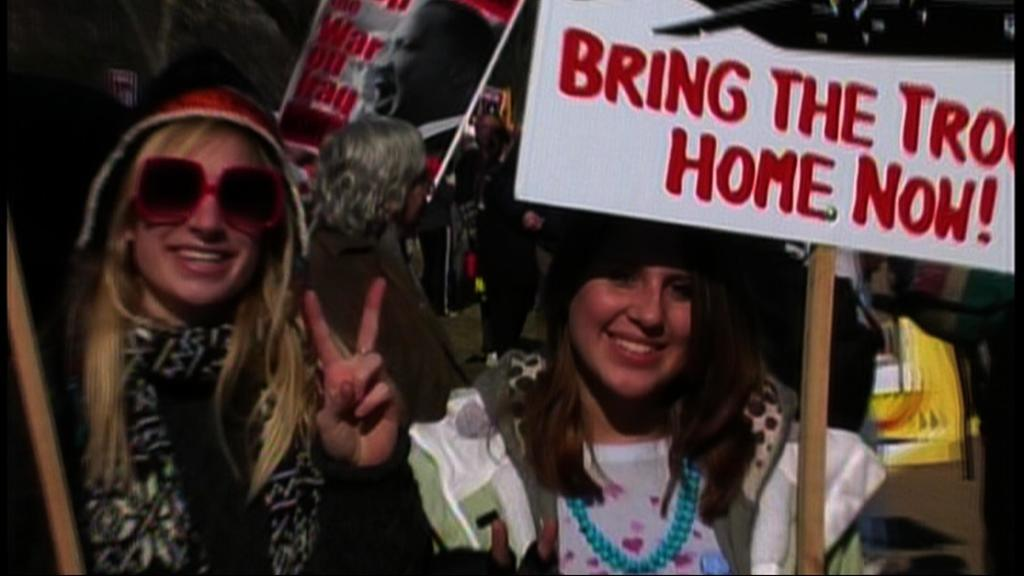How many women are in the foreground of the image? There are two women in the foreground of the image. What are the women doing in the image? The women are standing and holding placards in their hands. Can you describe the people in the background of the image? There are people holding placards in the background of the image. What type of linen is being used to cover the lamp in the image? There is no lamp or linen present in the image. What medical advice can the doctor provide to the women in the image? There is no doctor present in the image, so no medical advice can be provided. 